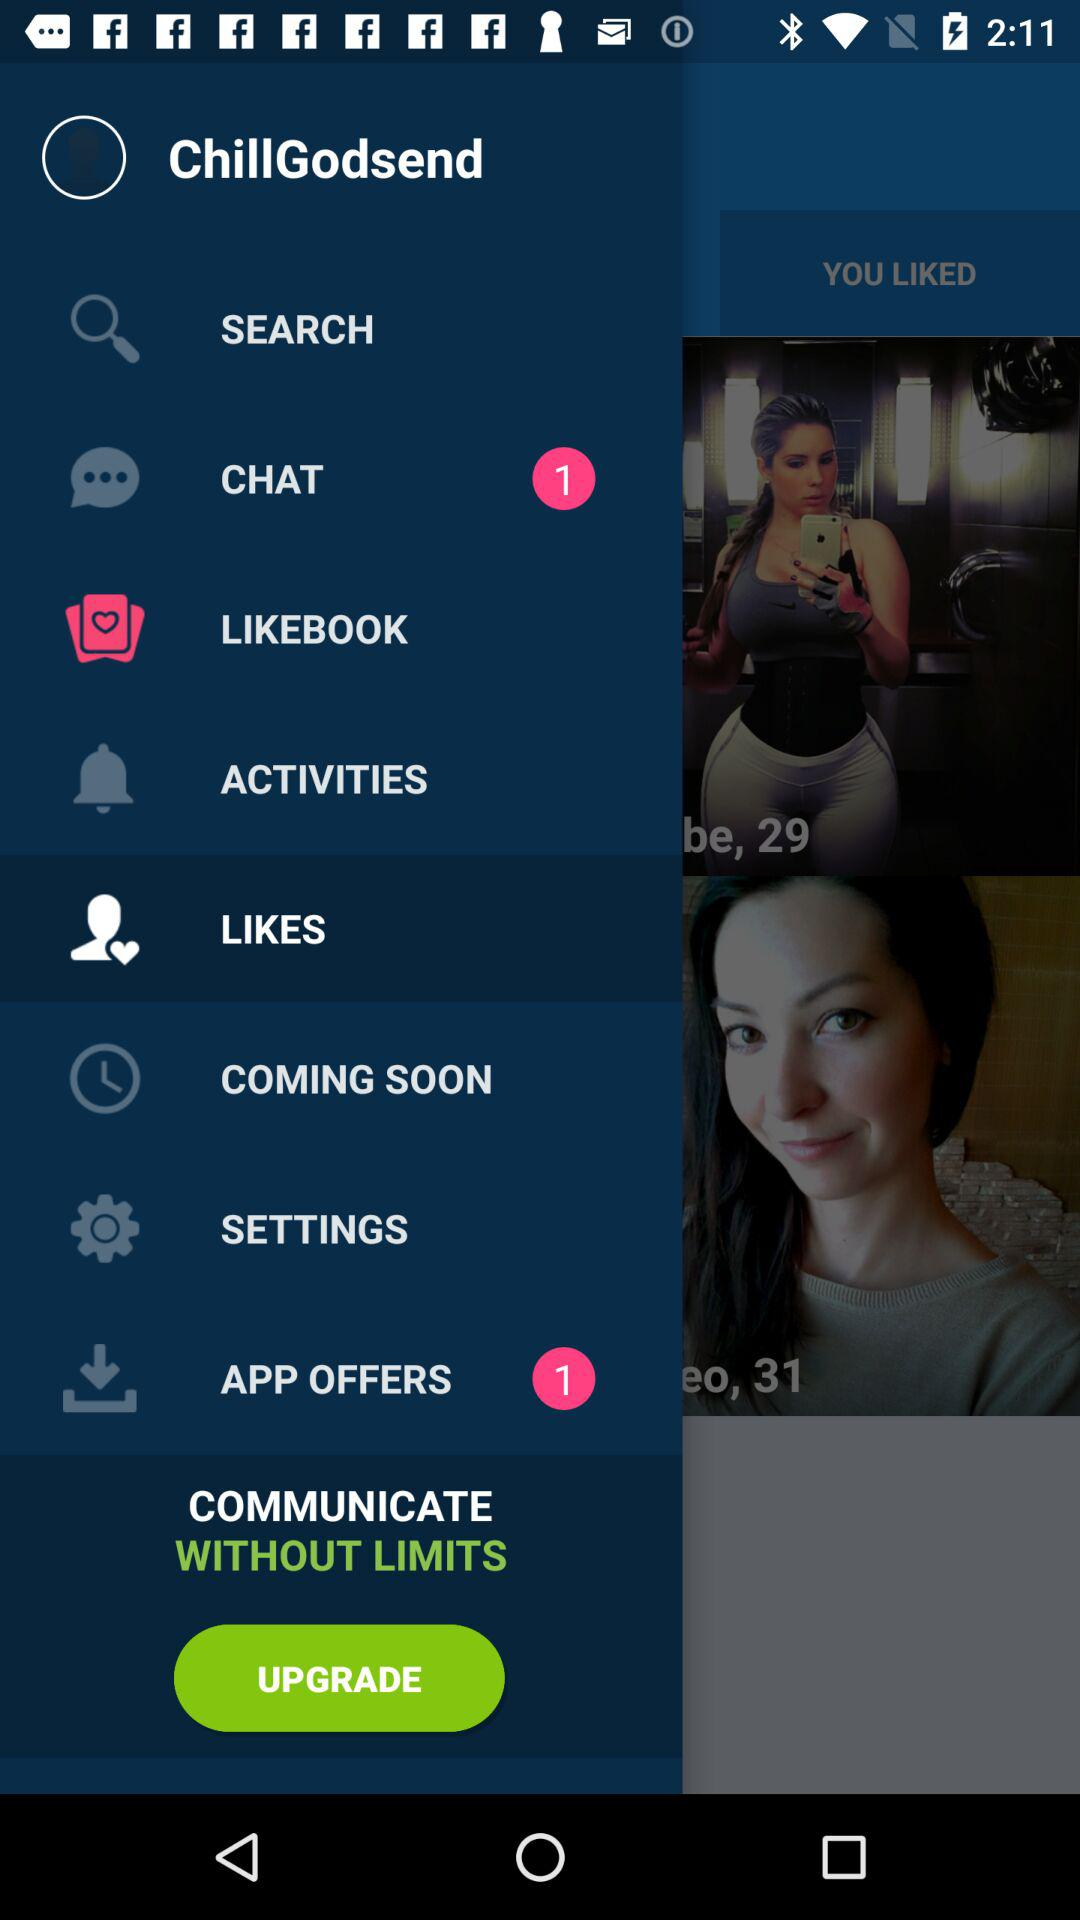How many unread "APP OFFERS" are there? There is 1 unread "APP OFFERS". 